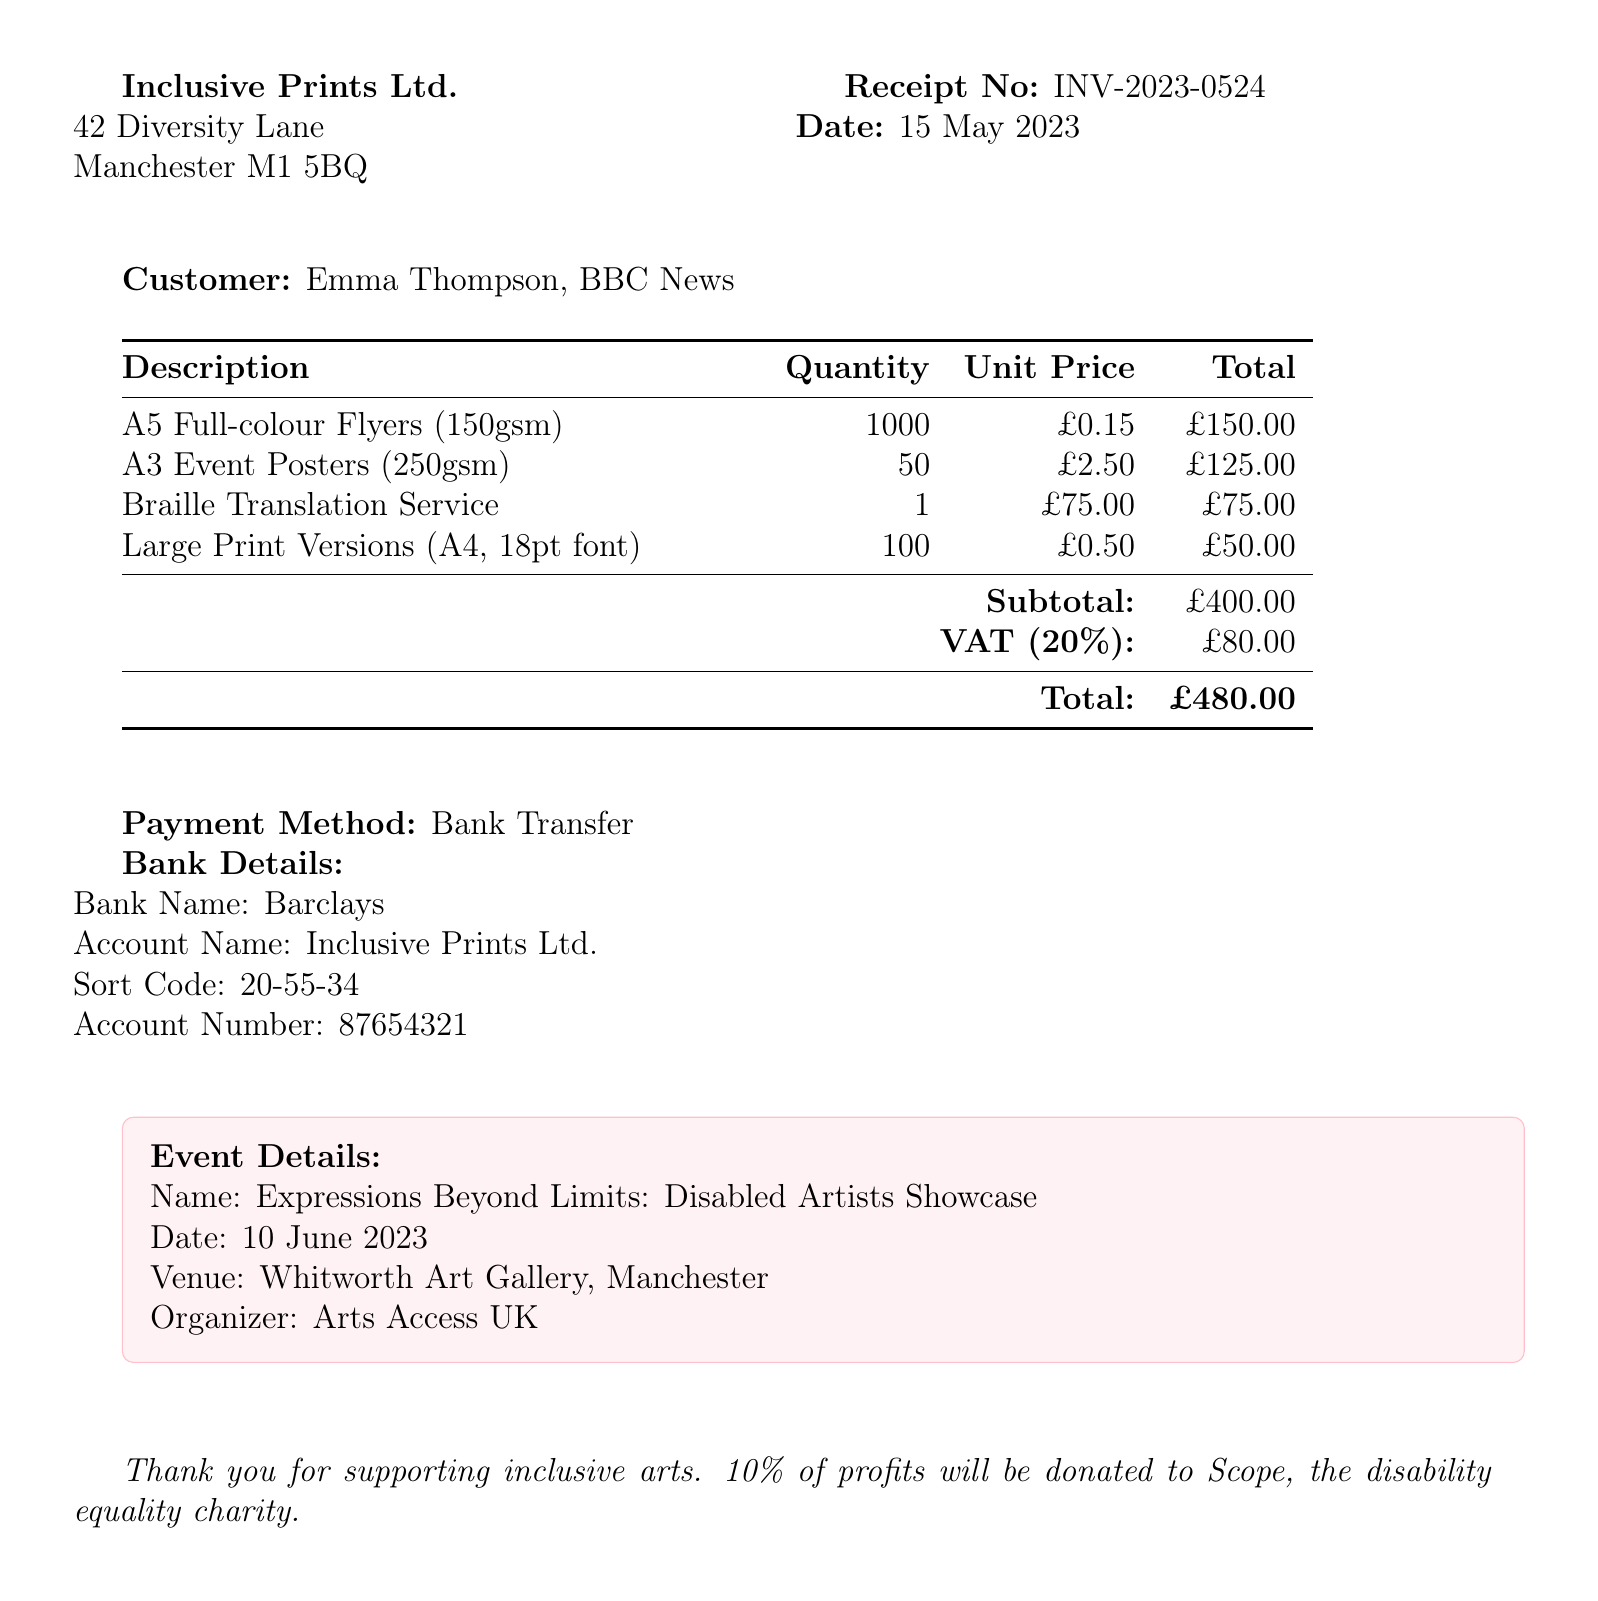What is the receipt number? The receipt number can be found at the top of the document as INV-2023-0524.
Answer: INV-2023-0524 What is the date of the receipt? The date of the receipt is stated clearly in the document as 15 May 2023.
Answer: 15 May 2023 What is the total amount due? The total amount due is calculated and displayed at the end of the document as £480.00.
Answer: £480.00 How many A5 flyers were printed? The quantity of A5 Full-colour Flyers printed, as listed in the item description, is 1000.
Answer: 1000 What service provides Braille translation? The Braille Translation Service is detailed as a separate item in the receipt.
Answer: Braille Translation Service What is the name of the event? The name of the event is highlighted in the Event Details section as Expressions Beyond Limits: Disabled Artists Showcase.
Answer: Expressions Beyond Limits: Disabled Artists Showcase Who is the organizer of the event? The organizer of the event is mentioned in the Event Details section as Arts Access UK.
Answer: Arts Access UK What percentage of profits will be donated to charity? The additional notes specify that 10% of profits will be donated to Scope, the disability equality charity.
Answer: 10% What method of payment was used? The payment method is indicated in the receipt and is Bank Transfer.
Answer: Bank Transfer 